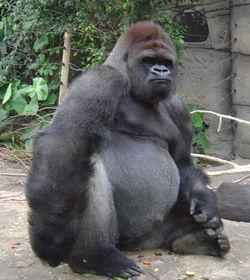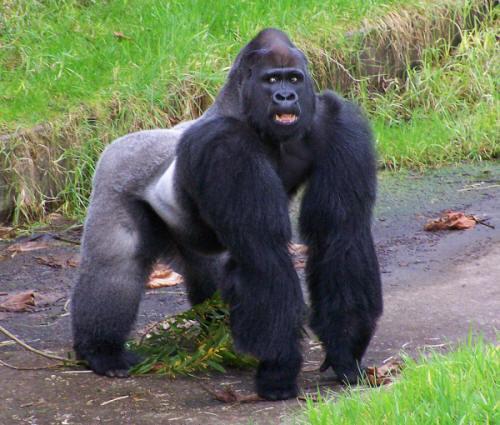The first image is the image on the left, the second image is the image on the right. For the images shown, is this caption "In the image to the right, a gorilla stands on all fours." true? Answer yes or no. Yes. The first image is the image on the left, the second image is the image on the right. Given the left and right images, does the statement "In the right image, there's a silverback gorilla standing on all fours." hold true? Answer yes or no. Yes. 